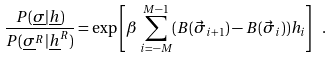<formula> <loc_0><loc_0><loc_500><loc_500>\frac { P ( \underline { \sigma } | \underline { h } ) } { P ( \underline { \sigma } ^ { R } | \underline { h } ^ { R } ) } = \exp \left [ \beta \sum _ { i = - M } ^ { M - 1 } ( B ( \vec { \sigma } _ { i + 1 } ) - B ( \vec { \sigma } _ { i } ) ) h _ { i } \right ] \ .</formula> 